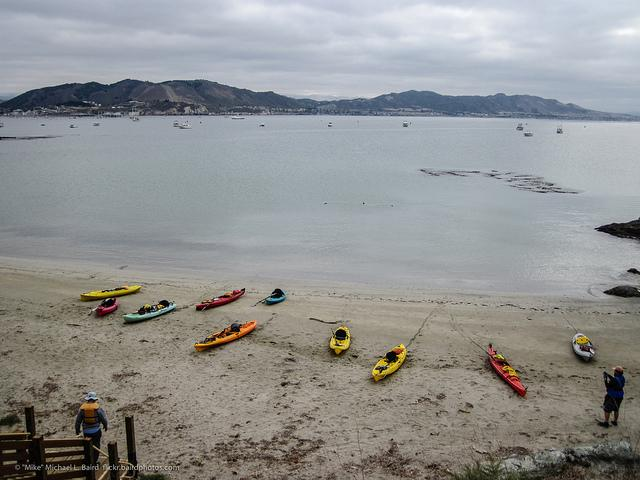What method do these vessels shown here normally gain movement? Please explain your reasoning. oars. Traditionally oars are used to move small non motor boats through water. 